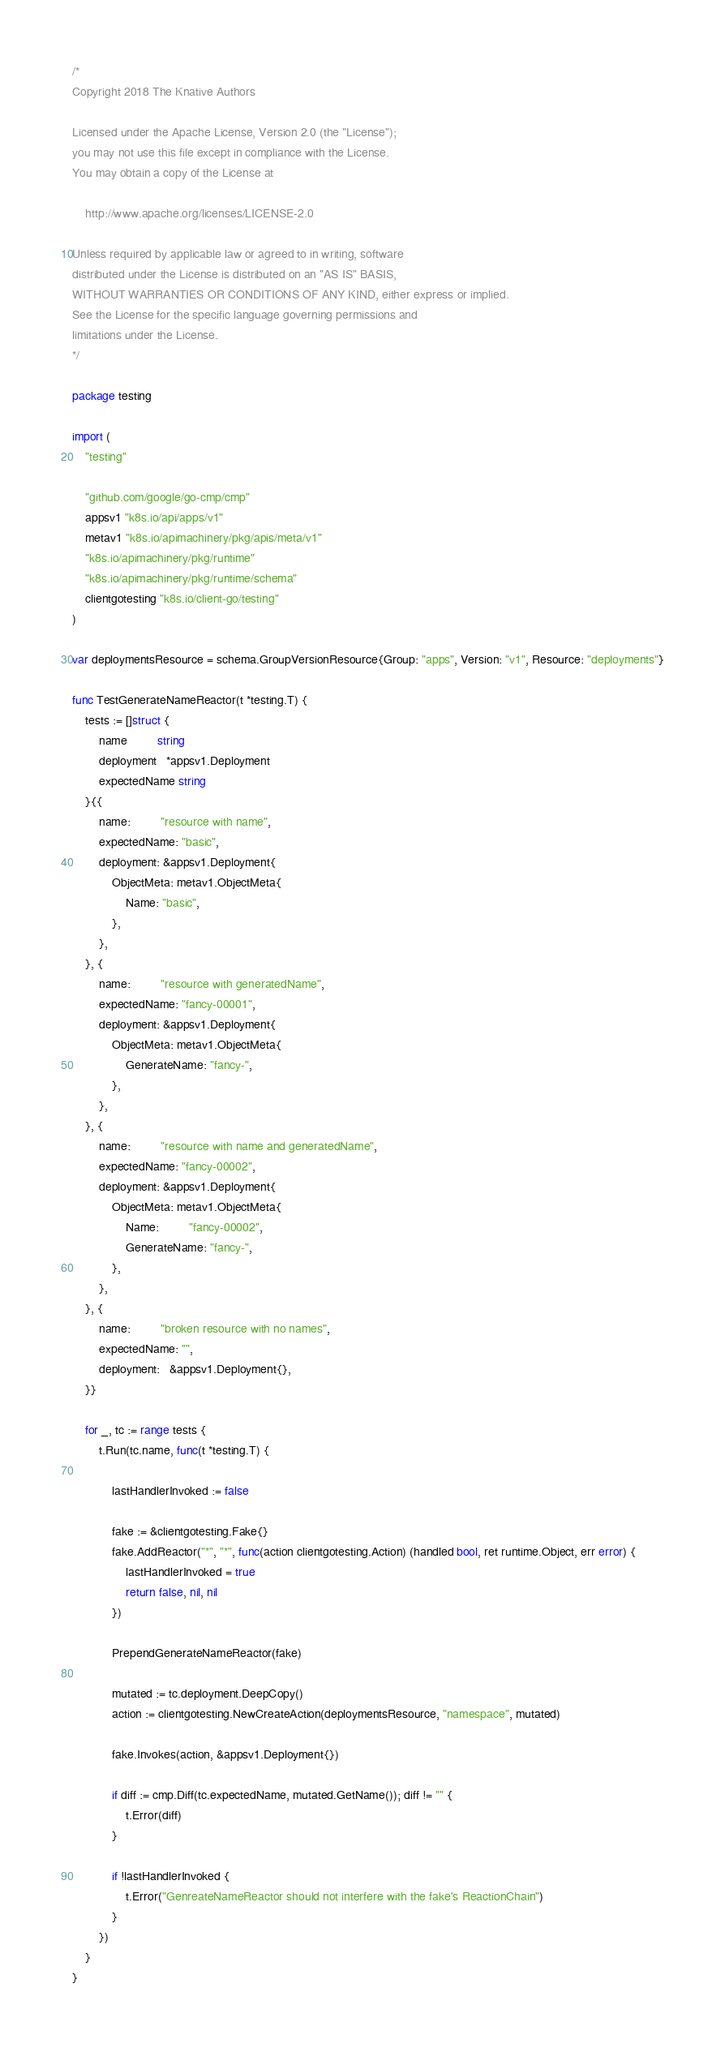<code> <loc_0><loc_0><loc_500><loc_500><_Go_>/*
Copyright 2018 The Knative Authors

Licensed under the Apache License, Version 2.0 (the "License");
you may not use this file except in compliance with the License.
You may obtain a copy of the License at

    http://www.apache.org/licenses/LICENSE-2.0

Unless required by applicable law or agreed to in writing, software
distributed under the License is distributed on an "AS IS" BASIS,
WITHOUT WARRANTIES OR CONDITIONS OF ANY KIND, either express or implied.
See the License for the specific language governing permissions and
limitations under the License.
*/

package testing

import (
	"testing"

	"github.com/google/go-cmp/cmp"
	appsv1 "k8s.io/api/apps/v1"
	metav1 "k8s.io/apimachinery/pkg/apis/meta/v1"
	"k8s.io/apimachinery/pkg/runtime"
	"k8s.io/apimachinery/pkg/runtime/schema"
	clientgotesting "k8s.io/client-go/testing"
)

var deploymentsResource = schema.GroupVersionResource{Group: "apps", Version: "v1", Resource: "deployments"}

func TestGenerateNameReactor(t *testing.T) {
	tests := []struct {
		name         string
		deployment   *appsv1.Deployment
		expectedName string
	}{{
		name:         "resource with name",
		expectedName: "basic",
		deployment: &appsv1.Deployment{
			ObjectMeta: metav1.ObjectMeta{
				Name: "basic",
			},
		},
	}, {
		name:         "resource with generatedName",
		expectedName: "fancy-00001",
		deployment: &appsv1.Deployment{
			ObjectMeta: metav1.ObjectMeta{
				GenerateName: "fancy-",
			},
		},
	}, {
		name:         "resource with name and generatedName",
		expectedName: "fancy-00002",
		deployment: &appsv1.Deployment{
			ObjectMeta: metav1.ObjectMeta{
				Name:         "fancy-00002",
				GenerateName: "fancy-",
			},
		},
	}, {
		name:         "broken resource with no names",
		expectedName: "",
		deployment:   &appsv1.Deployment{},
	}}

	for _, tc := range tests {
		t.Run(tc.name, func(t *testing.T) {

			lastHandlerInvoked := false

			fake := &clientgotesting.Fake{}
			fake.AddReactor("*", "*", func(action clientgotesting.Action) (handled bool, ret runtime.Object, err error) {
				lastHandlerInvoked = true
				return false, nil, nil
			})

			PrependGenerateNameReactor(fake)

			mutated := tc.deployment.DeepCopy()
			action := clientgotesting.NewCreateAction(deploymentsResource, "namespace", mutated)

			fake.Invokes(action, &appsv1.Deployment{})

			if diff := cmp.Diff(tc.expectedName, mutated.GetName()); diff != "" {
				t.Error(diff)
			}

			if !lastHandlerInvoked {
				t.Error("GenreateNameReactor should not interfere with the fake's ReactionChain")
			}
		})
	}
}
</code> 